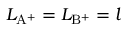<formula> <loc_0><loc_0><loc_500><loc_500>L _ { { A ^ { + } } } = L _ { { B ^ { + } } } = l</formula> 